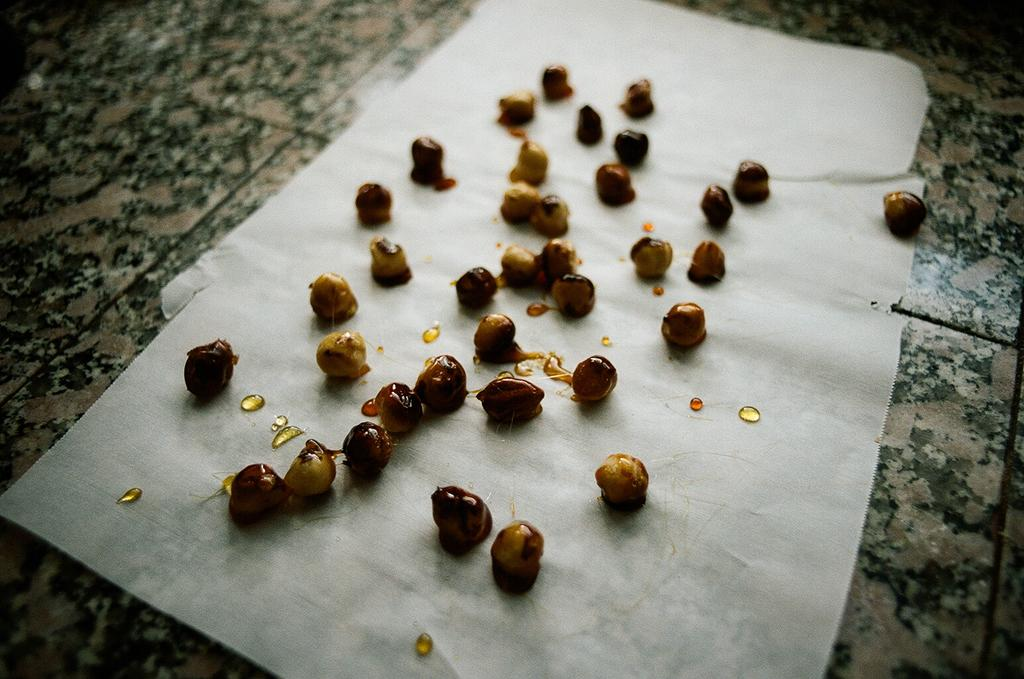What type of food is visible in the image? There are peanuts in the image. How are the peanuts arranged or presented? The peanuts are on a paper. Where is the paper with the peanuts located? The paper with the peanuts is on the floor. What type of vessel is used to tell a story in the image? There is no vessel or storytelling depicted in the image; it only features peanuts on a paper on the floor. 